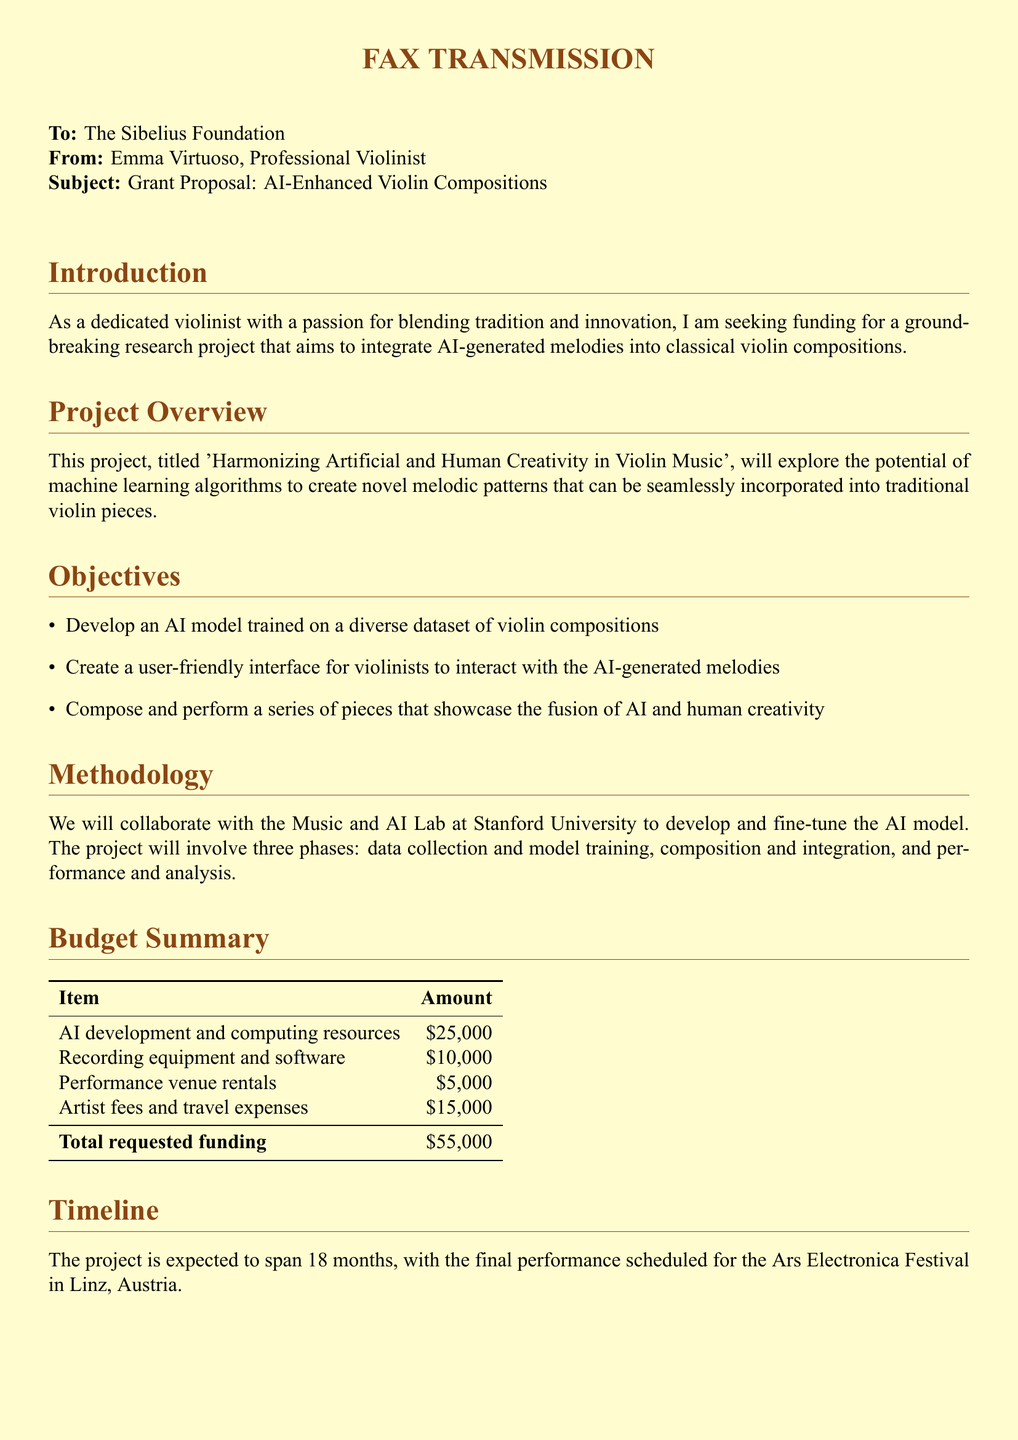What is the name of the project? The project aims to explore AI-generated melodies in violin compositions and is titled “Harmonizing Artificial and Human Creativity in Violin Music.”
Answer: Harmonizing Artificial and Human Creativity in Violin Music Who is the sender of the fax? The sender of the fax is identified as Emma Virtuoso, a professional violinist.
Answer: Emma Virtuoso What is the total requested funding amount? The total funding requested within the budget summary is the total of all budget items listed.
Answer: $55,000 How long is the project expected to last? The document outlines that the project is expected to span a duration of 18 months.
Answer: 18 months Which festival is the final performance scheduled for? The document states that the final performance will take place at the Ars Electronica Festival.
Answer: Ars Electronica Festival What institution will collaborate on the AI model development? The document specifies that collaboration will occur with the Music and AI Lab at Stanford University.
Answer: Music and AI Lab at Stanford University What are the main objectives of the project? The objectives focus on developing an AI model, creating a user interface, and composing pieces that merge AI and human creativity.
Answer: Develop an AI model, create a user-friendly interface, compose and perform series of pieces What is the purpose of the research project? The research aims to integrate AI-generated melodies with traditional violin compositions, exploring machine learning for innovative music.
Answer: Integrate AI-generated melodies into classical violin compositions What is the budget for recording equipment and software? The document lists recording equipment and software expenses as part of the budget summary.
Answer: $10,000 What color is used in the document's background? The document features a light cream color as the background.
Answer: light cream 